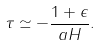Convert formula to latex. <formula><loc_0><loc_0><loc_500><loc_500>\tau \simeq - \frac { 1 + \epsilon } { a H } .</formula> 